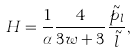<formula> <loc_0><loc_0><loc_500><loc_500>H = \frac { 1 } { \alpha } \frac { 4 } { 3 w + 3 } \frac { \tilde { p } _ { l } } { \tilde { l } } ,</formula> 